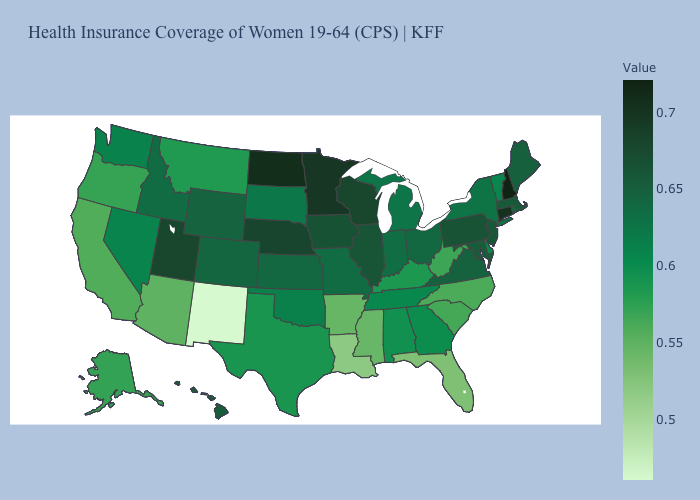Among the states that border New Jersey , does Delaware have the lowest value?
Be succinct. Yes. Among the states that border Wisconsin , does Michigan have the lowest value?
Answer briefly. Yes. Does Michigan have a higher value than New Mexico?
Give a very brief answer. Yes. Among the states that border Nebraska , does Wyoming have the lowest value?
Concise answer only. No. Does Nebraska have the lowest value in the MidWest?
Be succinct. No. Among the states that border Washington , which have the highest value?
Answer briefly. Idaho. 